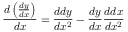<formula> <loc_0><loc_0><loc_500><loc_500>{ \frac { d \left ( { \frac { d y } { d x } } \right ) } { d x } } = { \frac { d d y } { d x ^ { 2 } } } - { \frac { d y } { d x } } { \frac { d d x } { d x ^ { 2 } } }</formula> 